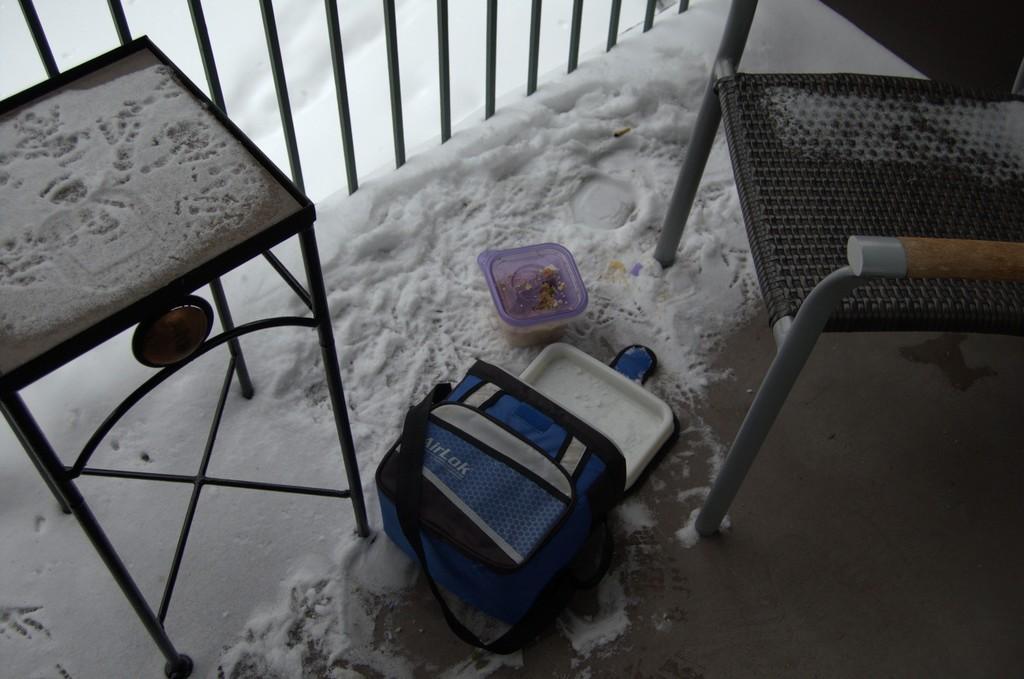Can you describe this image briefly? In the middle of the image there is a box and container and there are some chairs. Behind the container there is snow and fencing. 